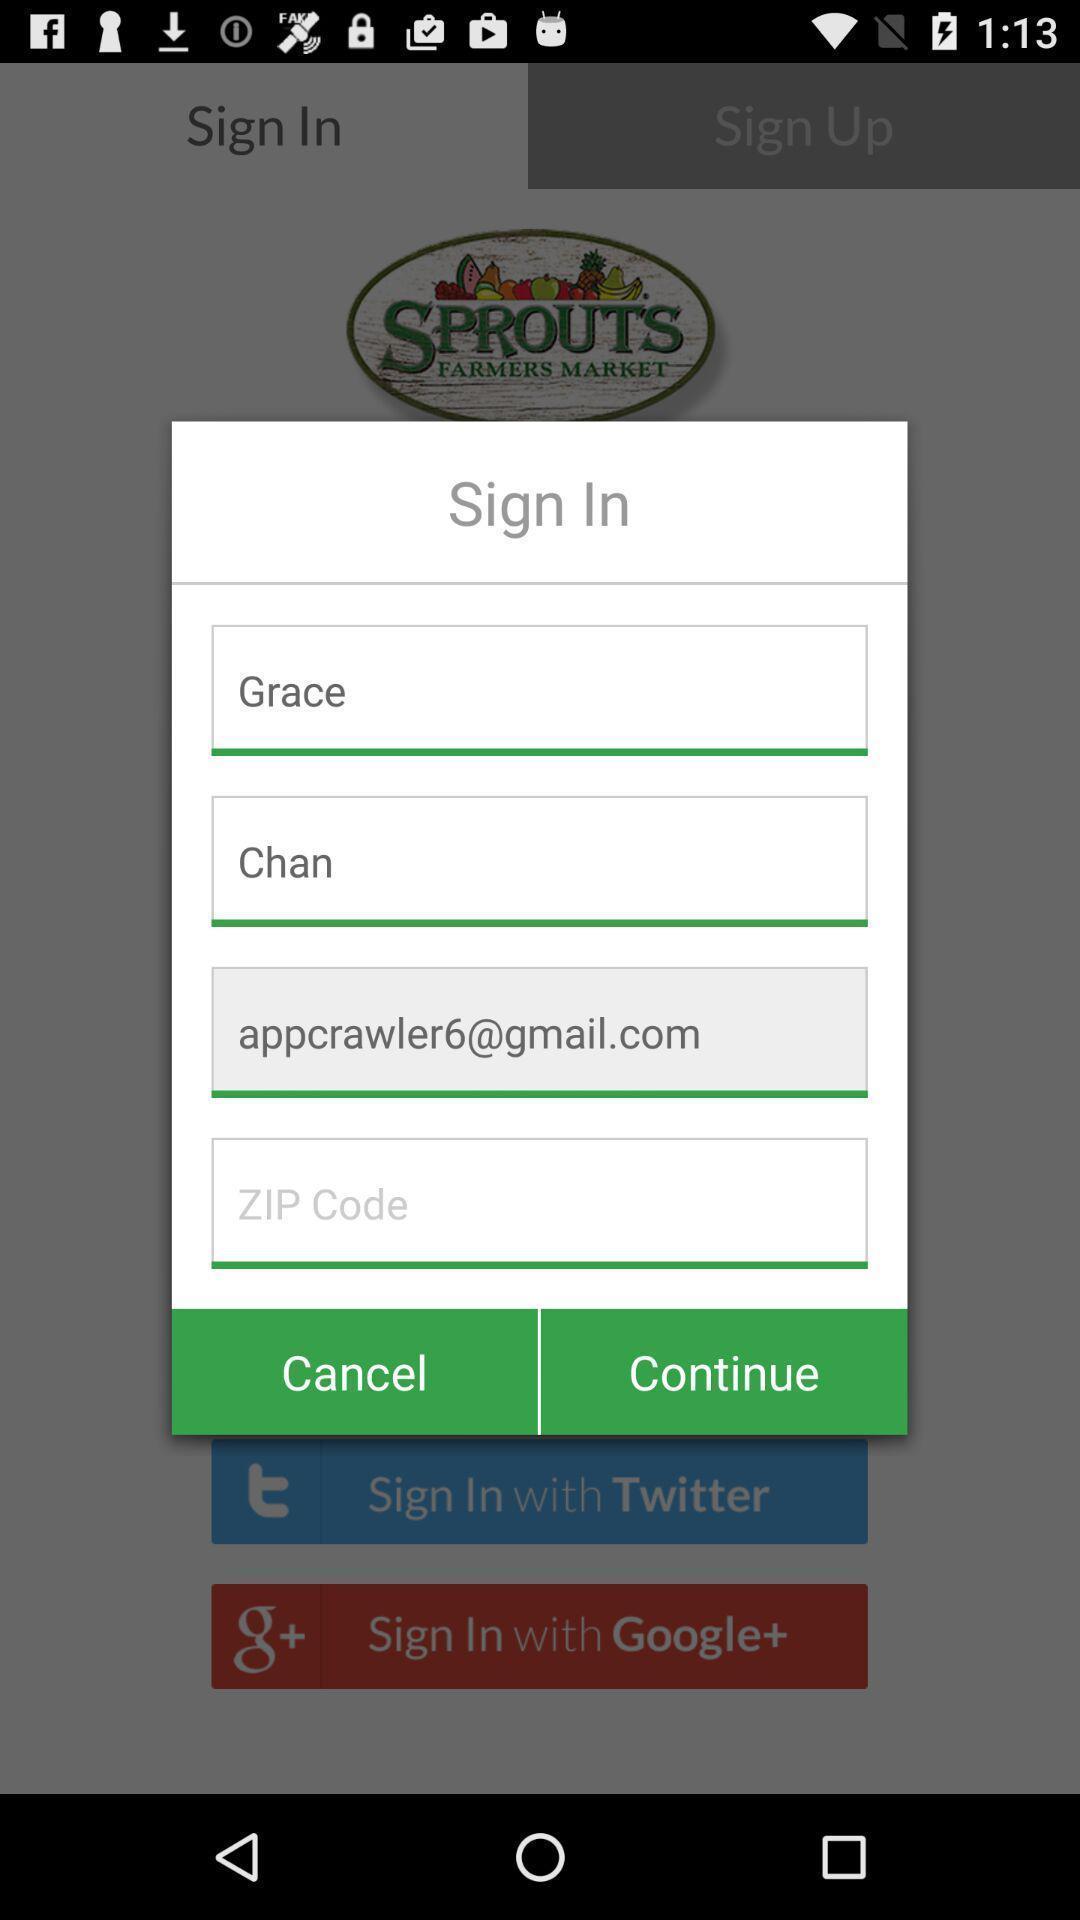Tell me what you see in this picture. Sign in page. 